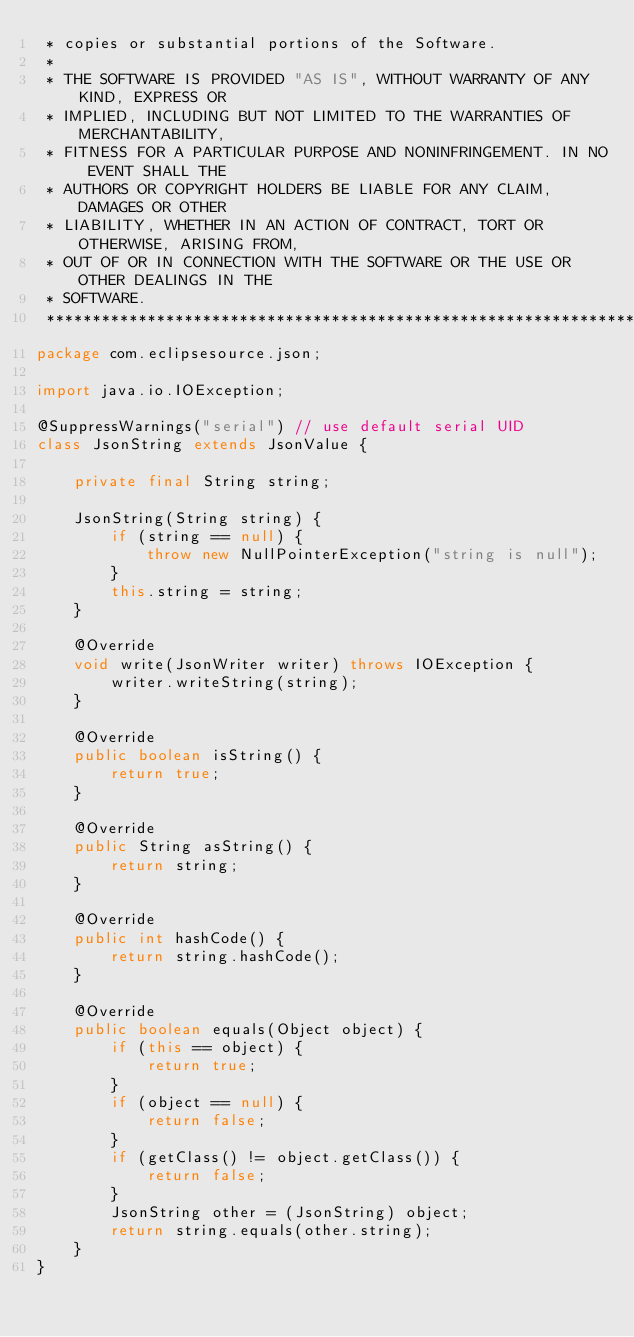Convert code to text. <code><loc_0><loc_0><loc_500><loc_500><_Java_> * copies or substantial portions of the Software.
 *
 * THE SOFTWARE IS PROVIDED "AS IS", WITHOUT WARRANTY OF ANY KIND, EXPRESS OR
 * IMPLIED, INCLUDING BUT NOT LIMITED TO THE WARRANTIES OF MERCHANTABILITY,
 * FITNESS FOR A PARTICULAR PURPOSE AND NONINFRINGEMENT. IN NO EVENT SHALL THE
 * AUTHORS OR COPYRIGHT HOLDERS BE LIABLE FOR ANY CLAIM, DAMAGES OR OTHER
 * LIABILITY, WHETHER IN AN ACTION OF CONTRACT, TORT OR OTHERWISE, ARISING FROM,
 * OUT OF OR IN CONNECTION WITH THE SOFTWARE OR THE USE OR OTHER DEALINGS IN THE
 * SOFTWARE.
 ******************************************************************************/
package com.eclipsesource.json;

import java.io.IOException;

@SuppressWarnings("serial") // use default serial UID
class JsonString extends JsonValue {

    private final String string;

    JsonString(String string) {
        if (string == null) {
            throw new NullPointerException("string is null");
        }
        this.string = string;
    }

    @Override
    void write(JsonWriter writer) throws IOException {
        writer.writeString(string);
    }

    @Override
    public boolean isString() {
        return true;
    }

    @Override
    public String asString() {
        return string;
    }

    @Override
    public int hashCode() {
        return string.hashCode();
    }

    @Override
    public boolean equals(Object object) {
        if (this == object) {
            return true;
        }
        if (object == null) {
            return false;
        }
        if (getClass() != object.getClass()) {
            return false;
        }
        JsonString other = (JsonString) object;
        return string.equals(other.string);
    }
}
</code> 